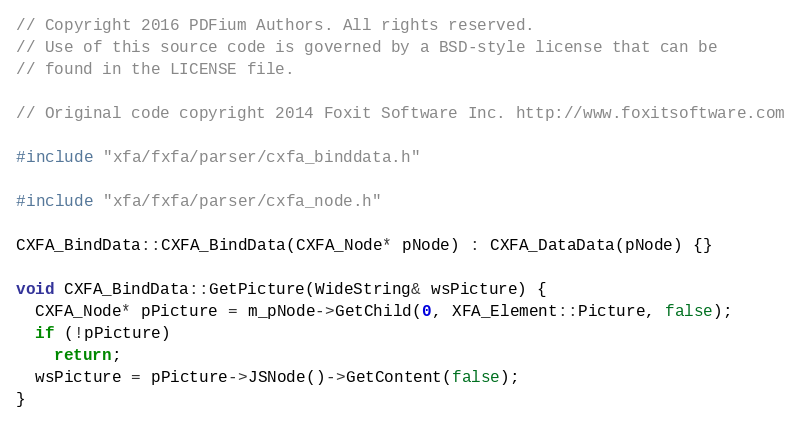<code> <loc_0><loc_0><loc_500><loc_500><_C++_>// Copyright 2016 PDFium Authors. All rights reserved.
// Use of this source code is governed by a BSD-style license that can be
// found in the LICENSE file.

// Original code copyright 2014 Foxit Software Inc. http://www.foxitsoftware.com

#include "xfa/fxfa/parser/cxfa_binddata.h"

#include "xfa/fxfa/parser/cxfa_node.h"

CXFA_BindData::CXFA_BindData(CXFA_Node* pNode) : CXFA_DataData(pNode) {}

void CXFA_BindData::GetPicture(WideString& wsPicture) {
  CXFA_Node* pPicture = m_pNode->GetChild(0, XFA_Element::Picture, false);
  if (!pPicture)
    return;
  wsPicture = pPicture->JSNode()->GetContent(false);
}
</code> 